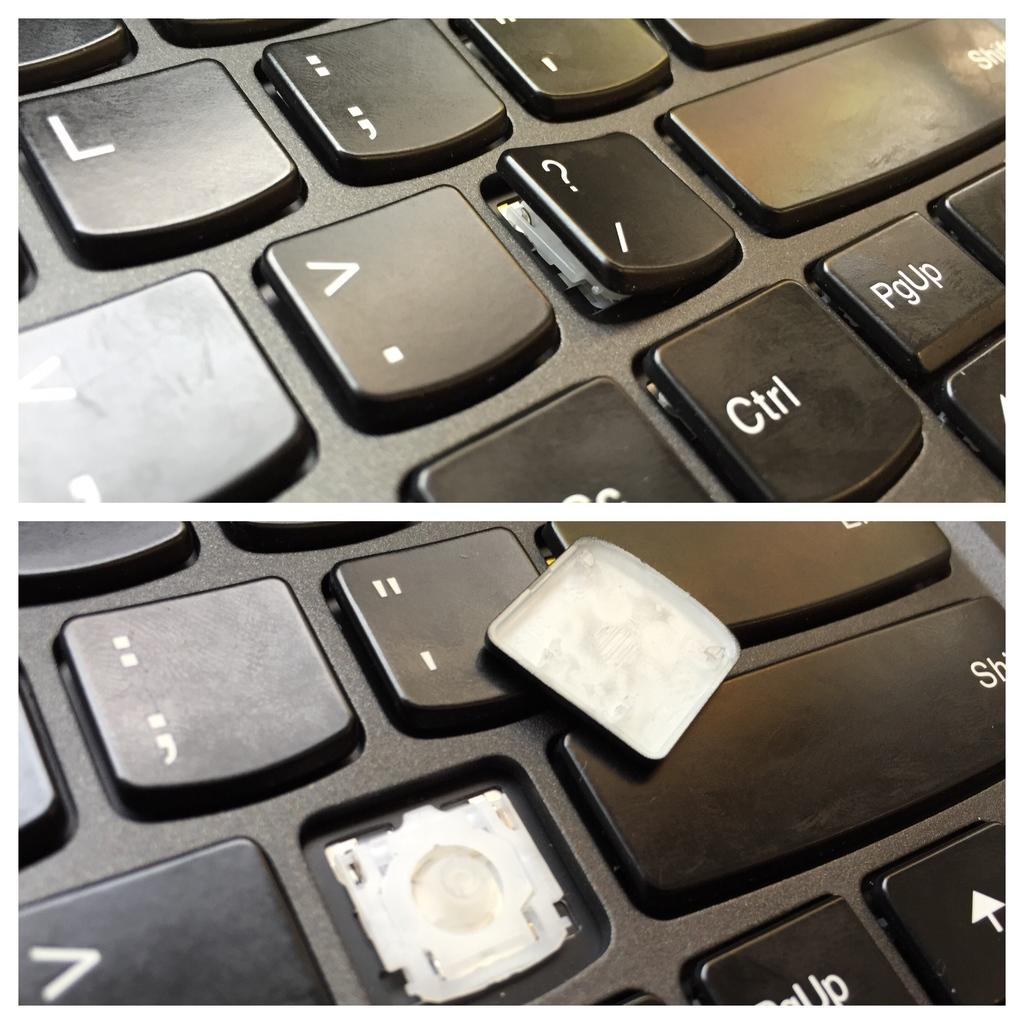<image>
Offer a succinct explanation of the picture presented. A keyboard with a broken key next to the shift key. 